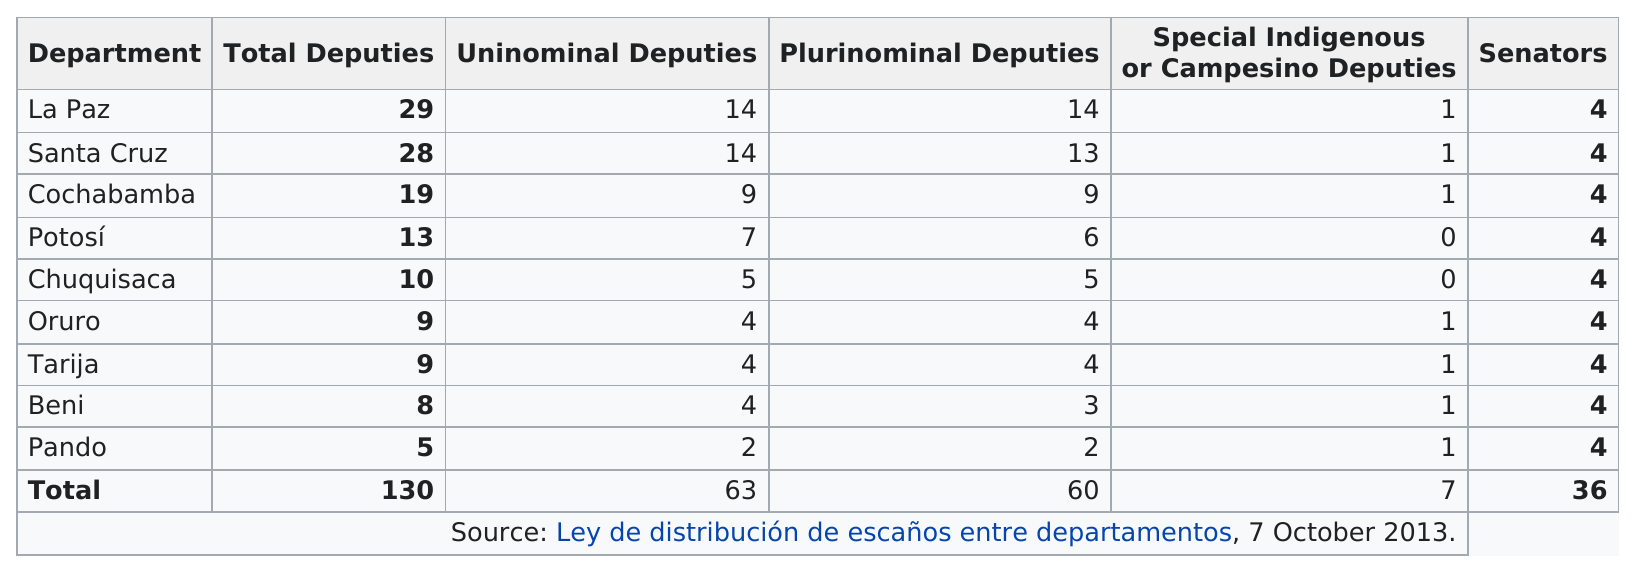Draw attention to some important aspects in this diagram. Benji has a total of 4 more deputies than state senators. The total number of senators in all departments is 36. There is a difference of three uninominal deputies between the deputies from Potosí and Beni. Does Oruro have more or less uninominal deputies than La Paz? It has less. There are more special indigenous or campesino deputies from Cochabamba than from Chuquisaca. 